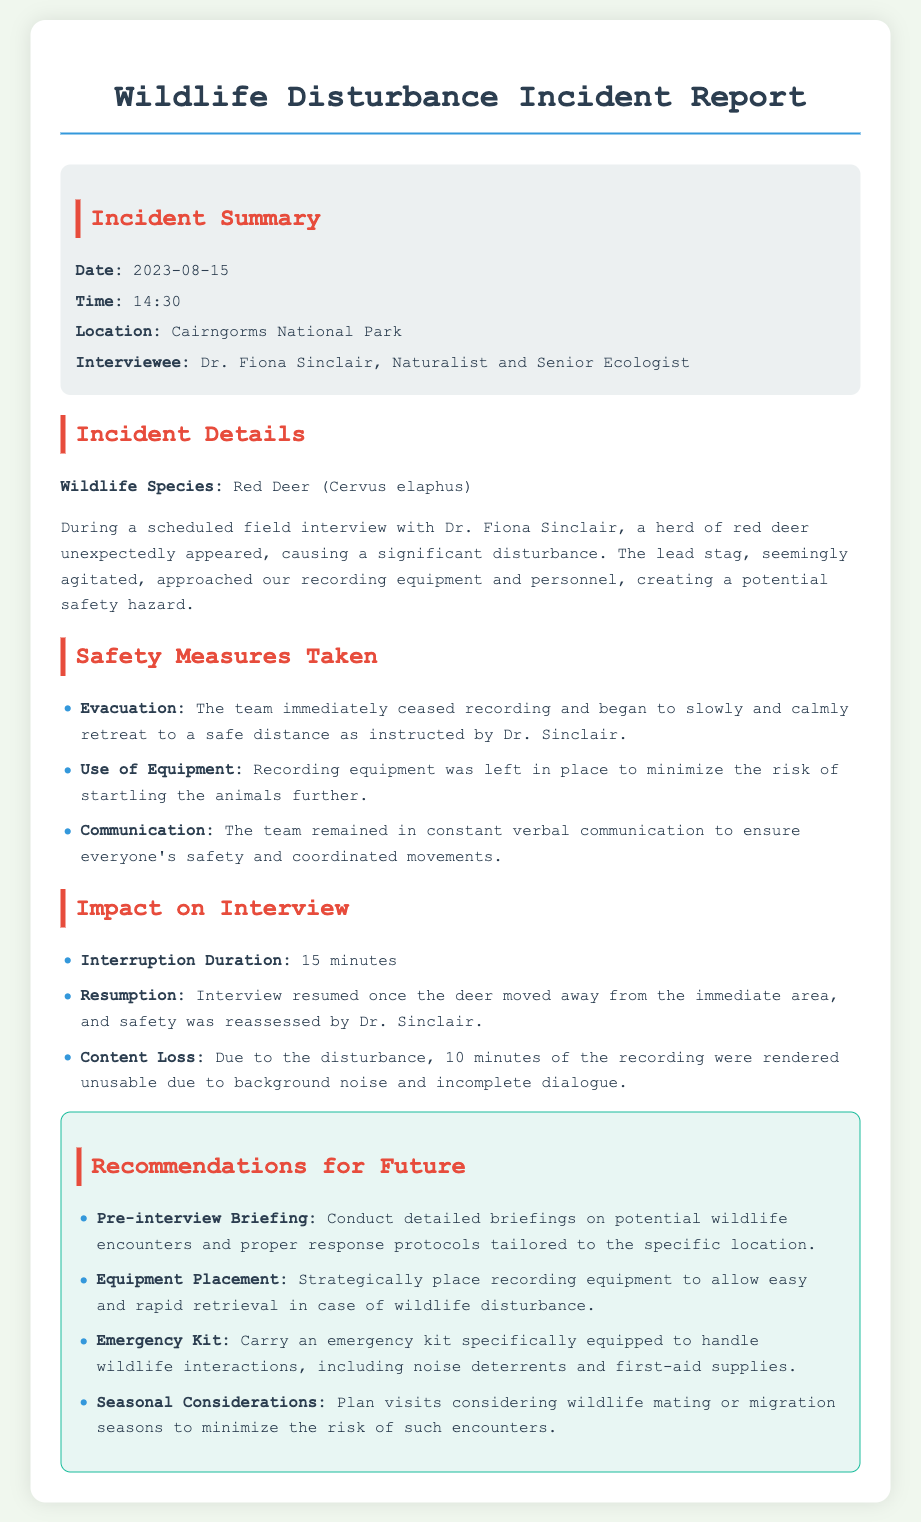What was the date of the incident? The incident occurred on August 15, 2023.
Answer: August 15, 2023 Who was the interviewee? The interviewee for the incident was Dr. Fiona Sinclair.
Answer: Dr. Fiona Sinclair What wildlife species caused the disturbance? The wildlife species involved in the disturbance was the Red Deer.
Answer: Red Deer How long was the interruption due to the disturbance? The interruption lasted for 15 minutes.
Answer: 15 minutes What percentage of the recording was rendered unusable? 10 minutes of the recording were unusable due to background noise and incomplete dialogue from a total of 30 minutes.
Answer: 33% What safety measure involved communication? The team remained in constant verbal communication for safety.
Answer: Communication What is one recommendation for future incidents? One recommendation is to conduct detailed briefings on potential wildlife encounters.
Answer: Pre-interview Briefing How was the recording equipment managed during the incident? The recording equipment was left in place to minimize risk.
Answer: Left in place What was the location of the incident? The location of the incident was Cairngorms National Park.
Answer: Cairngorms National Park 